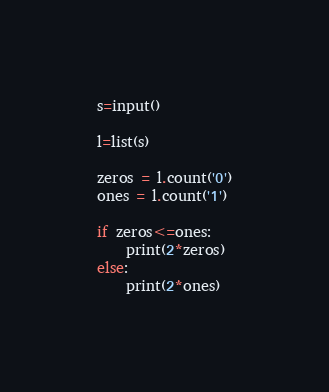Convert code to text. <code><loc_0><loc_0><loc_500><loc_500><_Python_>s=input()

l=list(s)

zeros = l.count('0')
ones = l.count('1')

if zeros<=ones:
    print(2*zeros)
else:
    print(2*ones)</code> 